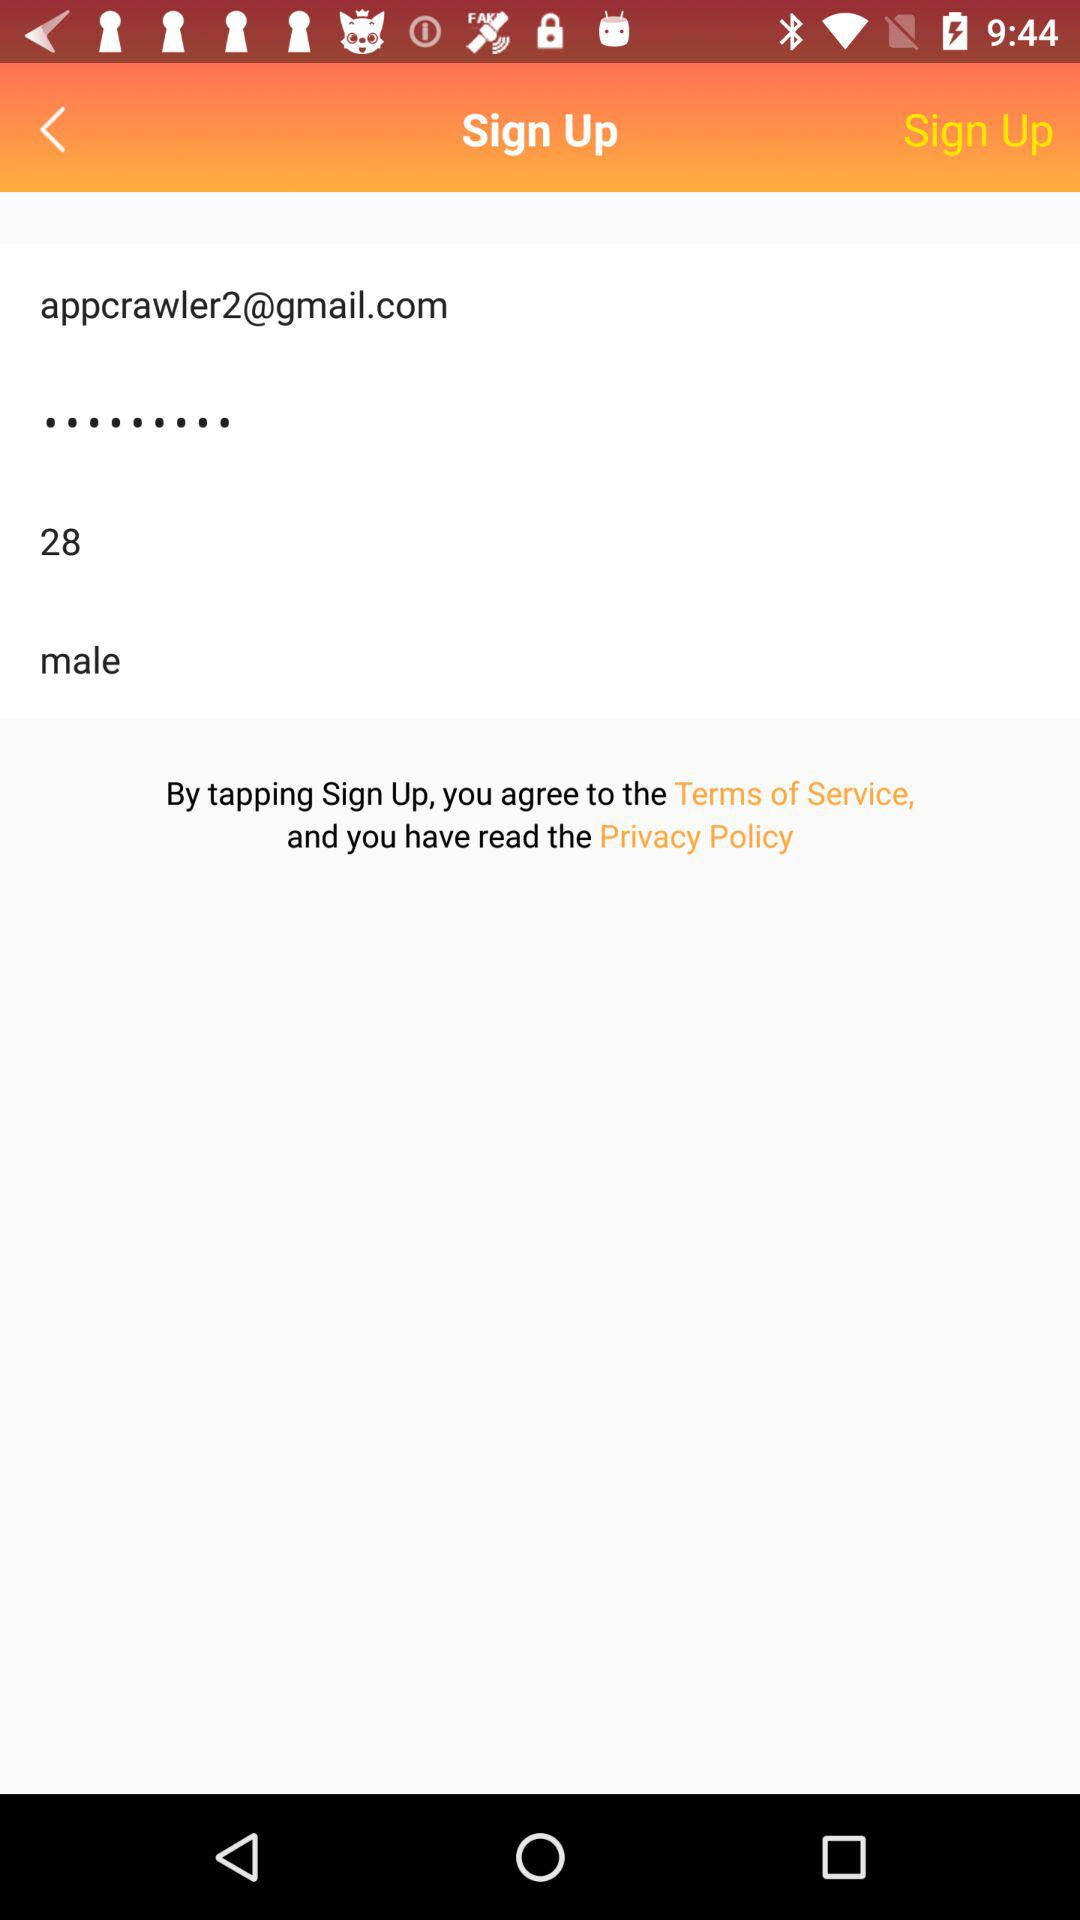What is the gender? The gender is male. 